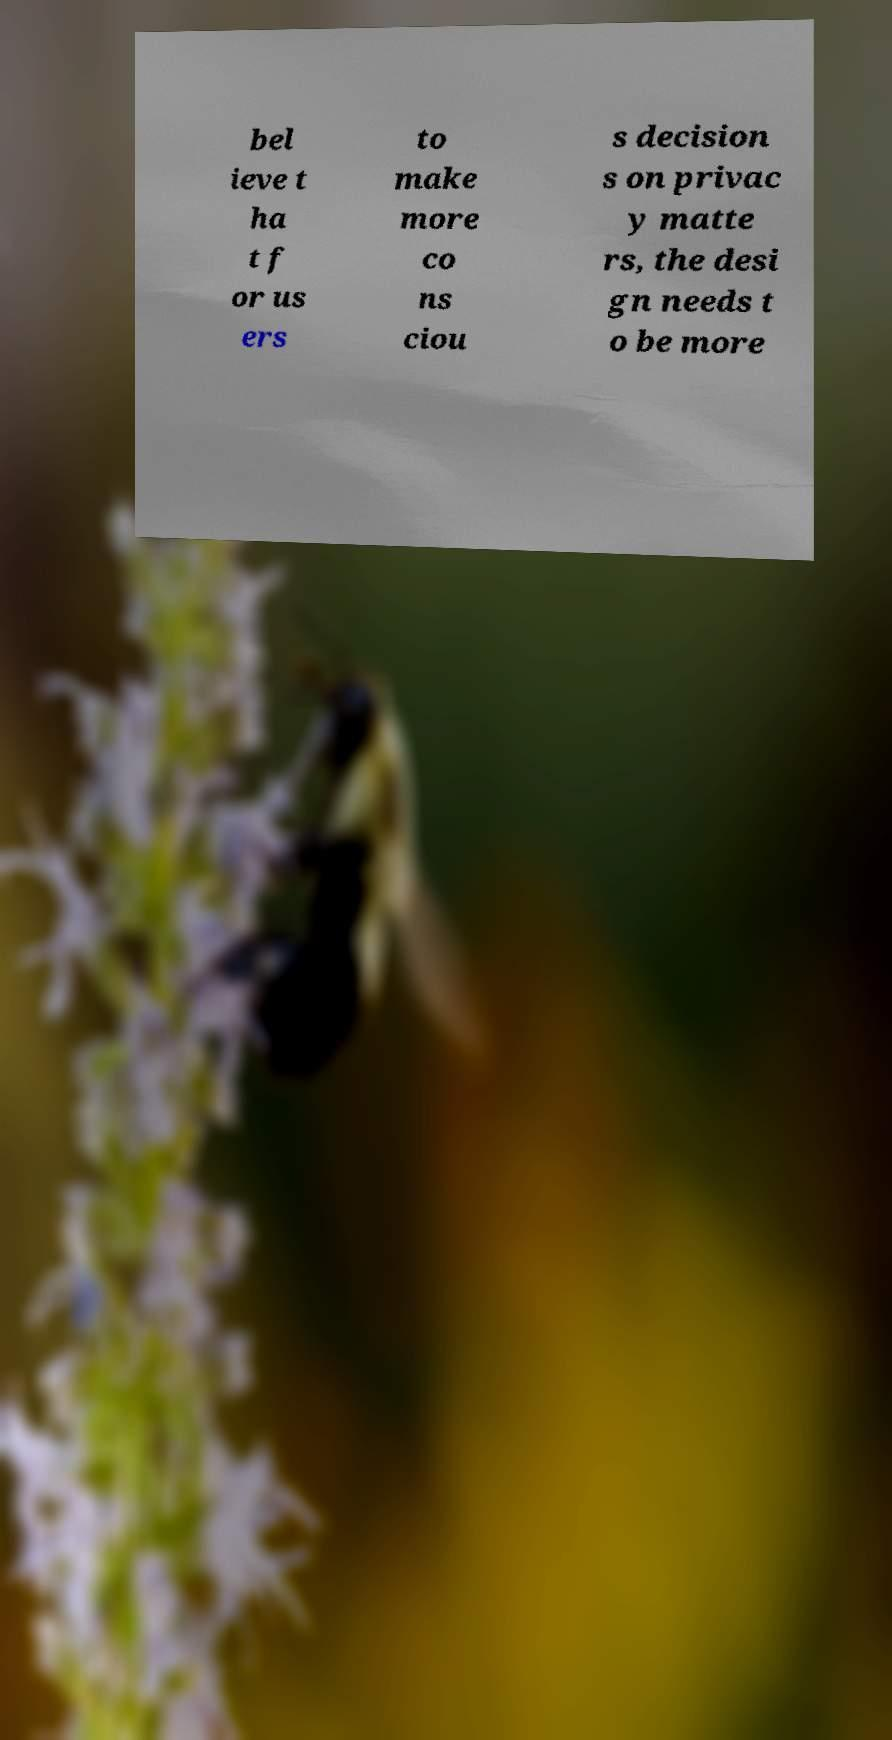Can you read and provide the text displayed in the image?This photo seems to have some interesting text. Can you extract and type it out for me? bel ieve t ha t f or us ers to make more co ns ciou s decision s on privac y matte rs, the desi gn needs t o be more 